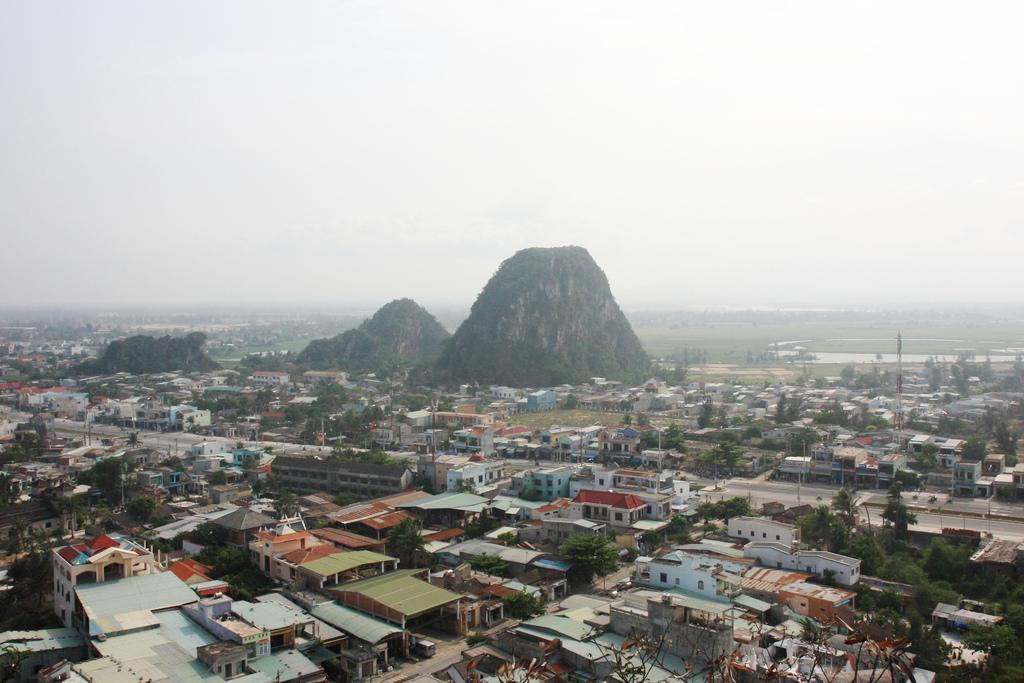What type of structures can be seen in the image? There are buildings and a tower in the image. What natural elements are present in the image? There are trees, grass, and two hills in the middle of the image. What man-made objects can be seen in the image? There are poles in the image. What is visible at the top of the image? The sky is visible at the top of the image. What type of test is being conducted on the hill in the image? There is no test being conducted in the image; it features buildings, trees, grass, poles, a tower, and two hills. What type of lunch is being served in the tower in the image? There is no lunch being served in the image; it only shows the tower and other elements mentioned in the facts. 